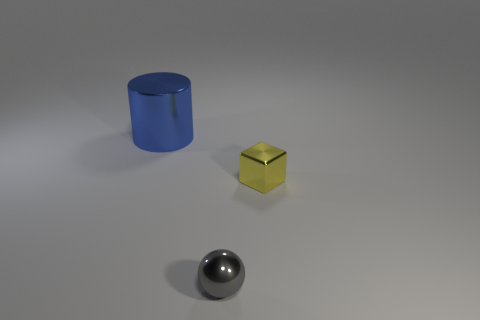Add 1 large metallic things. How many objects exist? 4 Subtract all blocks. How many objects are left? 2 Add 3 small blue matte balls. How many small blue matte balls exist? 3 Subtract 0 green cubes. How many objects are left? 3 Subtract all purple balls. Subtract all brown cubes. How many balls are left? 1 Subtract all large purple metal objects. Subtract all tiny shiny spheres. How many objects are left? 2 Add 2 small yellow shiny blocks. How many small yellow shiny blocks are left? 3 